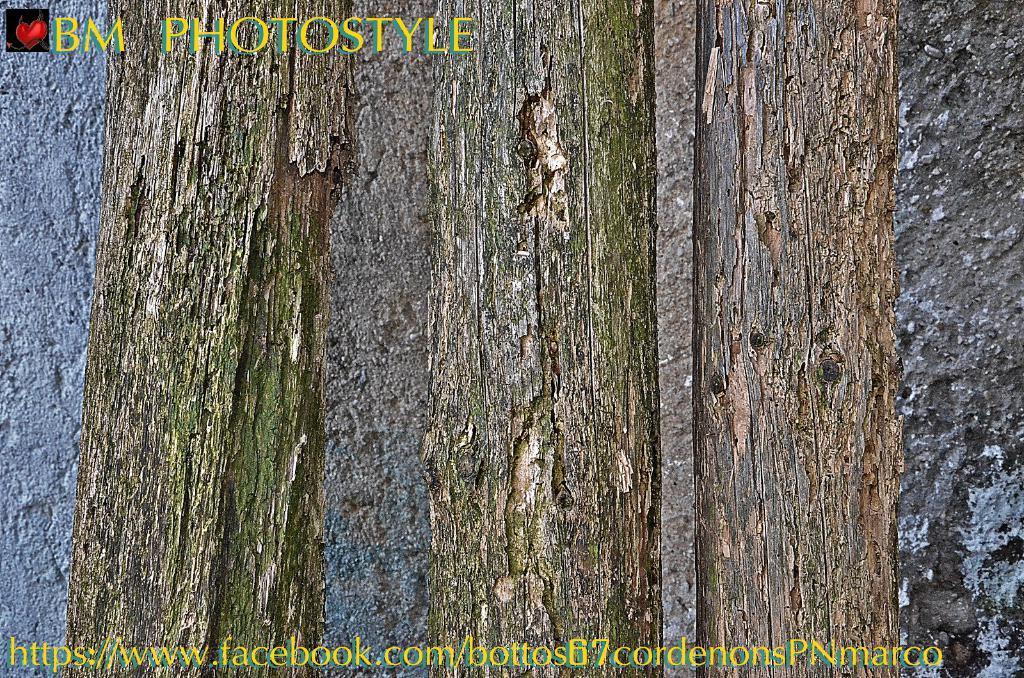In one or two sentences, can you explain what this image depicts? This image consists of trees. In the background, there is a wall. At the bottom, there is a text. 